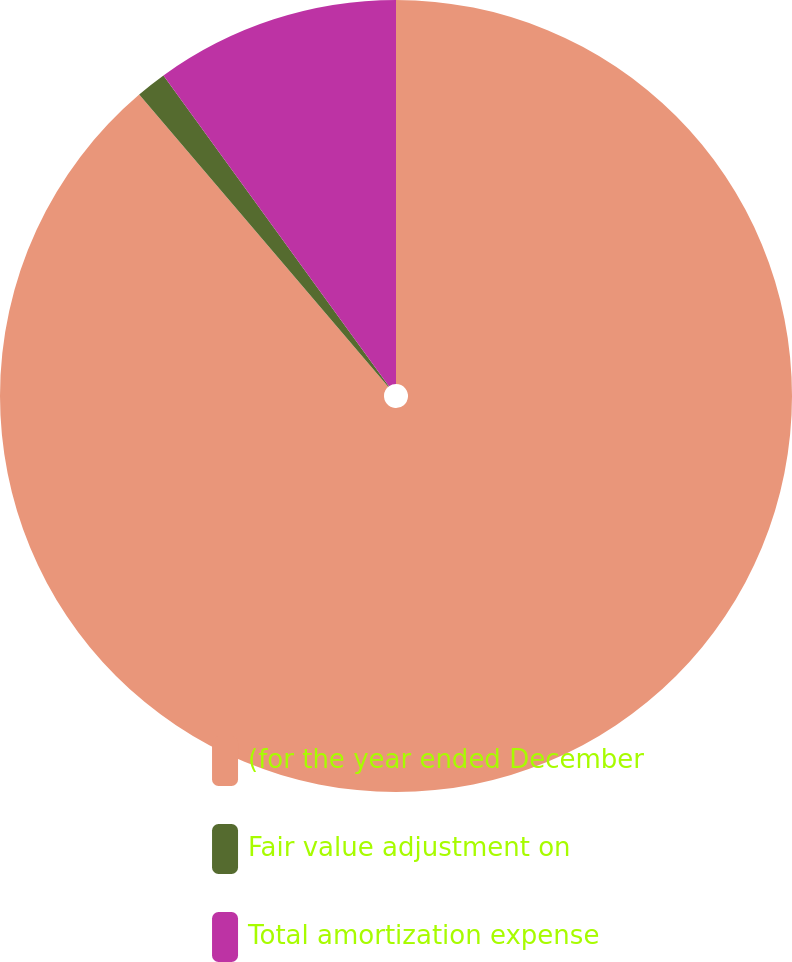Convert chart. <chart><loc_0><loc_0><loc_500><loc_500><pie_chart><fcel>(for the year ended December<fcel>Fair value adjustment on<fcel>Total amortization expense<nl><fcel>88.77%<fcel>1.24%<fcel>9.99%<nl></chart> 